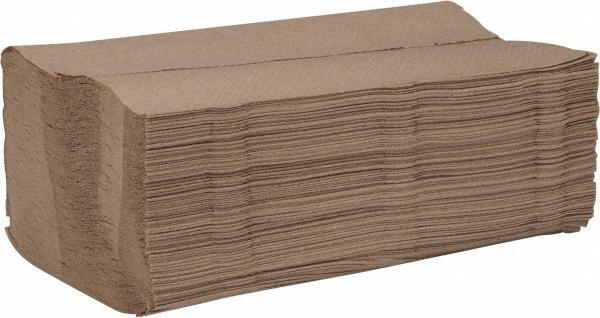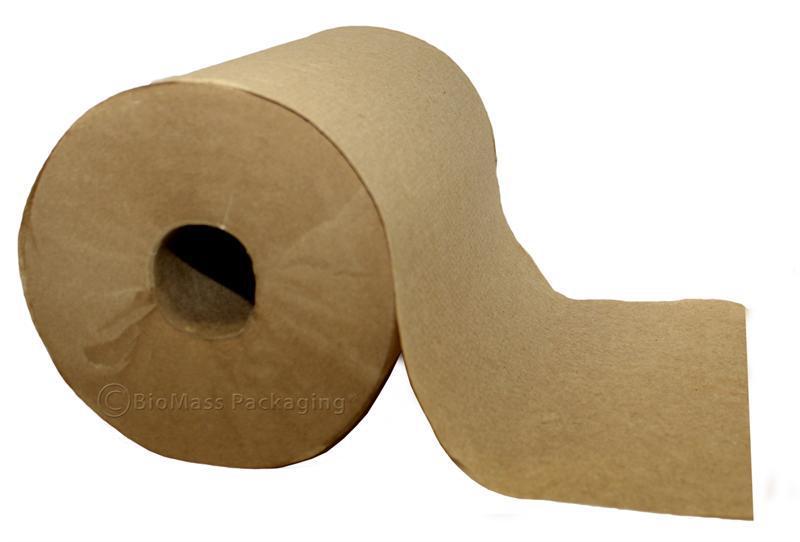The first image is the image on the left, the second image is the image on the right. For the images displayed, is the sentence "Both paper rolls and paper towel stacks are shown." factually correct? Answer yes or no. Yes. The first image is the image on the left, the second image is the image on the right. Considering the images on both sides, is "There is at least one roll of brown paper in the image on the left." valid? Answer yes or no. No. 